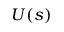Convert formula to latex. <formula><loc_0><loc_0><loc_500><loc_500>U ( s )</formula> 